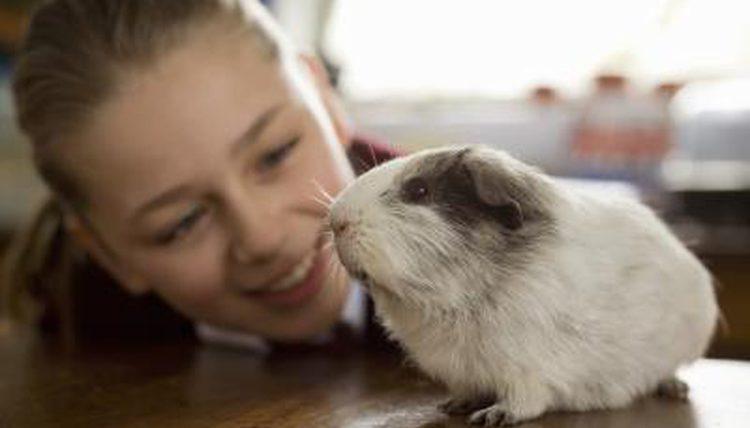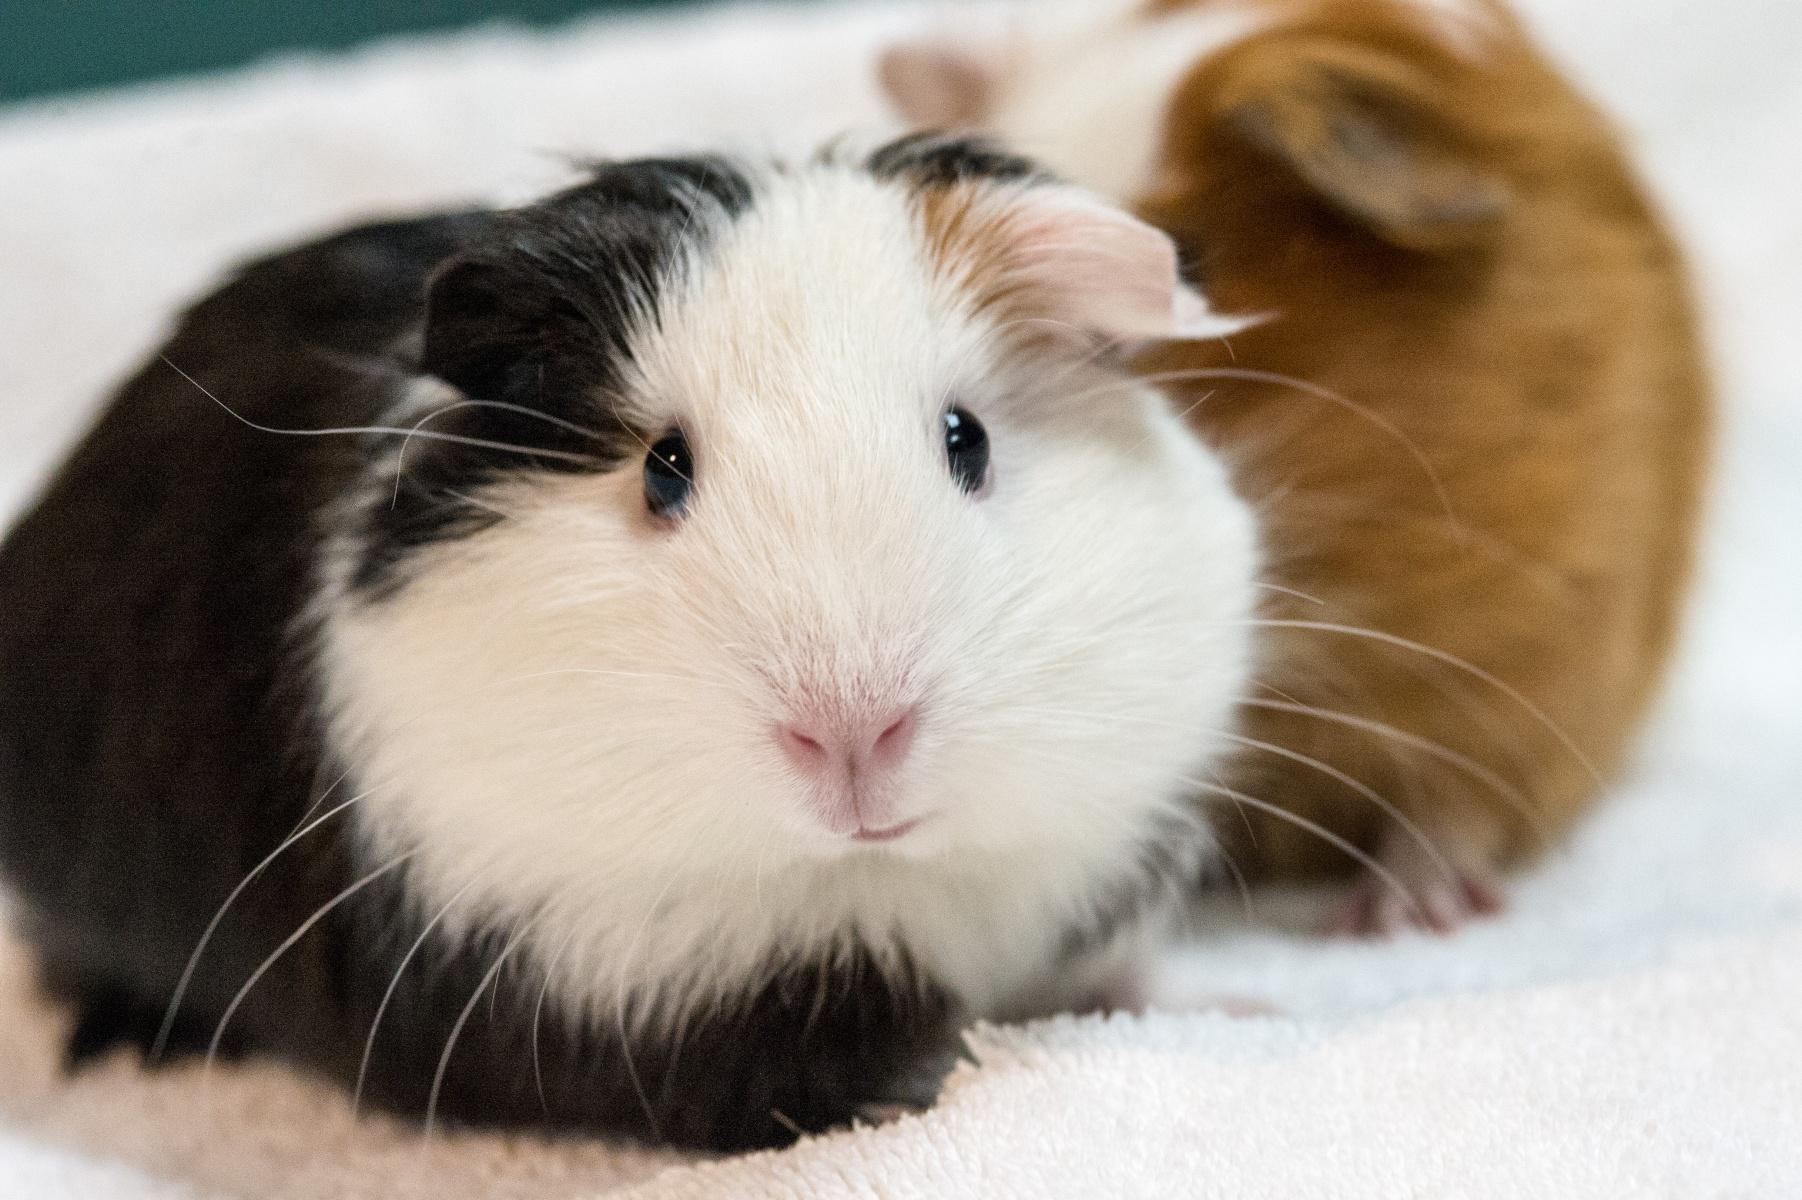The first image is the image on the left, the second image is the image on the right. Examine the images to the left and right. Is the description "In one image there are two guinea pigs eating grass." accurate? Answer yes or no. No. The first image is the image on the left, the second image is the image on the right. Given the left and right images, does the statement "One of the images includes part of a human." hold true? Answer yes or no. Yes. 